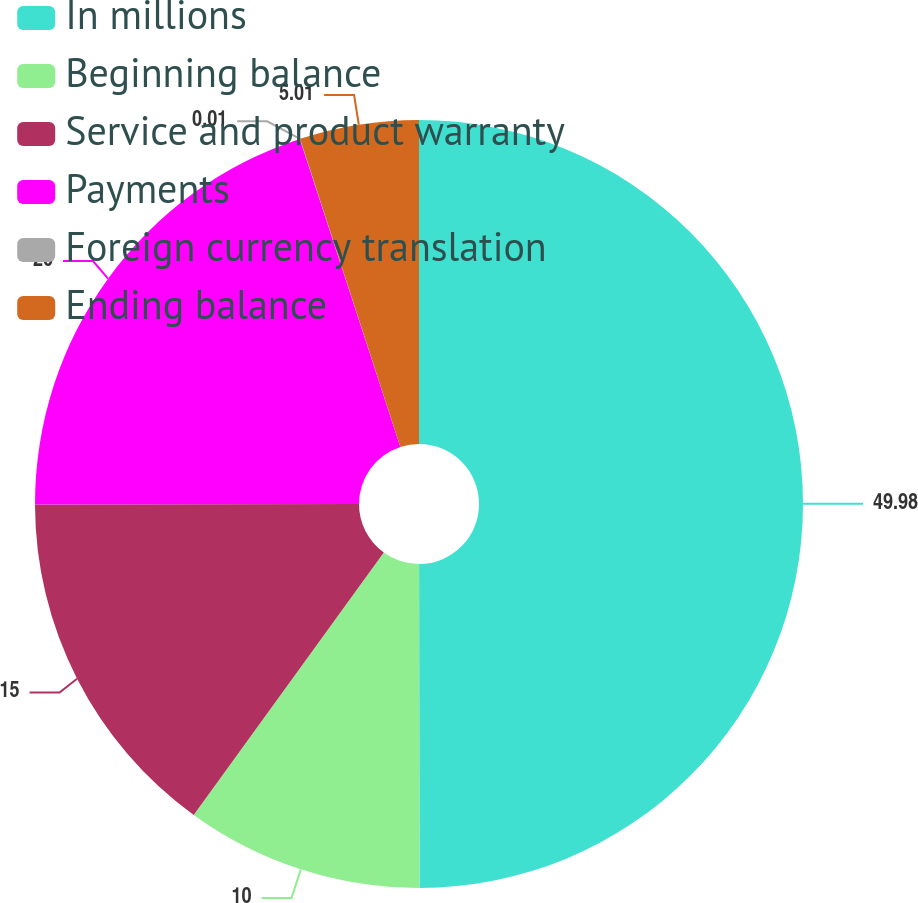<chart> <loc_0><loc_0><loc_500><loc_500><pie_chart><fcel>In millions<fcel>Beginning balance<fcel>Service and product warranty<fcel>Payments<fcel>Foreign currency translation<fcel>Ending balance<nl><fcel>49.98%<fcel>10.0%<fcel>15.0%<fcel>20.0%<fcel>0.01%<fcel>5.01%<nl></chart> 